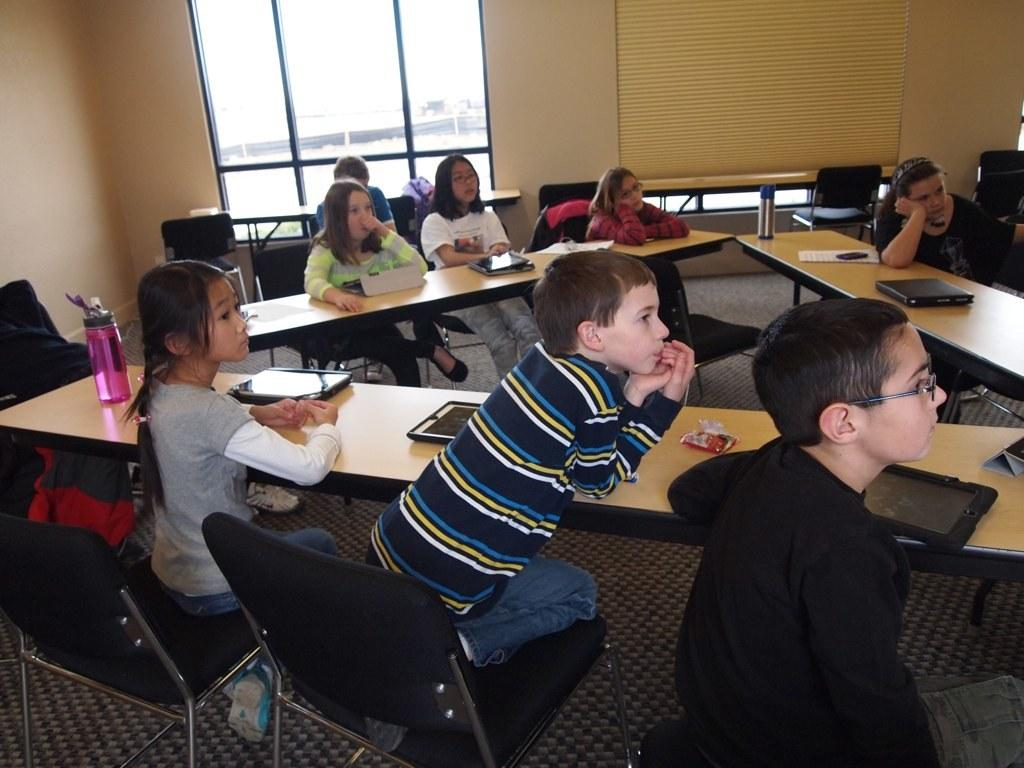What are the people in the image doing? There is a group of people sitting in chairs. What is on the table in the image? There is a bottle, iPads, and a laptop on the table. What type of flooring is visible in the image? There is a carpet in the image. What can be seen in the background of the image? There is a window in the background. What type of grape is being used to design the laptop in the image? There is no grape present in the image, and the laptop is not being designed. 